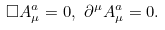Convert formula to latex. <formula><loc_0><loc_0><loc_500><loc_500>\square A _ { \mu } ^ { a } = 0 , \text { } \partial ^ { \mu } A _ { \mu } ^ { a } = 0 .</formula> 